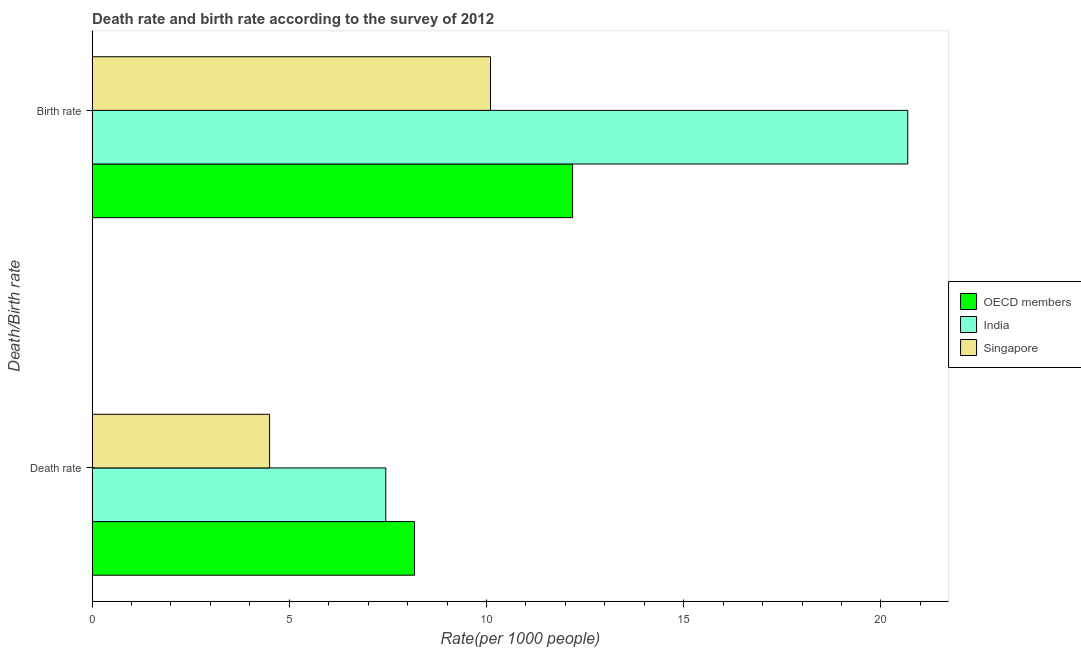How many different coloured bars are there?
Keep it short and to the point. 3. Are the number of bars on each tick of the Y-axis equal?
Provide a succinct answer. Yes. How many bars are there on the 1st tick from the top?
Provide a short and direct response. 3. What is the label of the 1st group of bars from the top?
Keep it short and to the point. Birth rate. What is the death rate in OECD members?
Your response must be concise. 8.17. Across all countries, what is the maximum birth rate?
Make the answer very short. 20.68. Across all countries, what is the minimum death rate?
Provide a short and direct response. 4.5. In which country was the death rate minimum?
Your response must be concise. Singapore. What is the total birth rate in the graph?
Give a very brief answer. 42.96. What is the difference between the birth rate in India and that in OECD members?
Your response must be concise. 8.5. What is the difference between the birth rate in Singapore and the death rate in India?
Provide a succinct answer. 2.65. What is the average birth rate per country?
Your answer should be compact. 14.32. In how many countries, is the death rate greater than 17 ?
Offer a terse response. 0. What is the ratio of the birth rate in Singapore to that in India?
Make the answer very short. 0.49. Is the death rate in Singapore less than that in India?
Provide a succinct answer. Yes. In how many countries, is the birth rate greater than the average birth rate taken over all countries?
Your answer should be very brief. 1. What does the 2nd bar from the top in Death rate represents?
Your answer should be very brief. India. What does the 1st bar from the bottom in Death rate represents?
Your response must be concise. OECD members. What is the difference between two consecutive major ticks on the X-axis?
Keep it short and to the point. 5. Does the graph contain grids?
Keep it short and to the point. No. How many legend labels are there?
Offer a very short reply. 3. How are the legend labels stacked?
Ensure brevity in your answer.  Vertical. What is the title of the graph?
Give a very brief answer. Death rate and birth rate according to the survey of 2012. What is the label or title of the X-axis?
Give a very brief answer. Rate(per 1000 people). What is the label or title of the Y-axis?
Give a very brief answer. Death/Birth rate. What is the Rate(per 1000 people) of OECD members in Death rate?
Provide a succinct answer. 8.17. What is the Rate(per 1000 people) in India in Death rate?
Offer a terse response. 7.45. What is the Rate(per 1000 people) in Singapore in Death rate?
Keep it short and to the point. 4.5. What is the Rate(per 1000 people) of OECD members in Birth rate?
Your response must be concise. 12.18. What is the Rate(per 1000 people) of India in Birth rate?
Offer a very short reply. 20.68. Across all Death/Birth rate, what is the maximum Rate(per 1000 people) in OECD members?
Your answer should be very brief. 12.18. Across all Death/Birth rate, what is the maximum Rate(per 1000 people) in India?
Your answer should be compact. 20.68. Across all Death/Birth rate, what is the minimum Rate(per 1000 people) in OECD members?
Provide a short and direct response. 8.17. Across all Death/Birth rate, what is the minimum Rate(per 1000 people) in India?
Ensure brevity in your answer.  7.45. Across all Death/Birth rate, what is the minimum Rate(per 1000 people) in Singapore?
Your response must be concise. 4.5. What is the total Rate(per 1000 people) of OECD members in the graph?
Your answer should be compact. 20.36. What is the total Rate(per 1000 people) of India in the graph?
Make the answer very short. 28.12. What is the difference between the Rate(per 1000 people) of OECD members in Death rate and that in Birth rate?
Offer a terse response. -4.01. What is the difference between the Rate(per 1000 people) of India in Death rate and that in Birth rate?
Provide a succinct answer. -13.23. What is the difference between the Rate(per 1000 people) of Singapore in Death rate and that in Birth rate?
Keep it short and to the point. -5.6. What is the difference between the Rate(per 1000 people) in OECD members in Death rate and the Rate(per 1000 people) in India in Birth rate?
Ensure brevity in your answer.  -12.5. What is the difference between the Rate(per 1000 people) in OECD members in Death rate and the Rate(per 1000 people) in Singapore in Birth rate?
Give a very brief answer. -1.93. What is the difference between the Rate(per 1000 people) of India in Death rate and the Rate(per 1000 people) of Singapore in Birth rate?
Offer a terse response. -2.65. What is the average Rate(per 1000 people) of OECD members per Death/Birth rate?
Provide a short and direct response. 10.18. What is the average Rate(per 1000 people) in India per Death/Birth rate?
Keep it short and to the point. 14.06. What is the difference between the Rate(per 1000 people) of OECD members and Rate(per 1000 people) of India in Death rate?
Offer a very short reply. 0.73. What is the difference between the Rate(per 1000 people) of OECD members and Rate(per 1000 people) of Singapore in Death rate?
Provide a succinct answer. 3.67. What is the difference between the Rate(per 1000 people) in India and Rate(per 1000 people) in Singapore in Death rate?
Your response must be concise. 2.95. What is the difference between the Rate(per 1000 people) of OECD members and Rate(per 1000 people) of India in Birth rate?
Provide a short and direct response. -8.5. What is the difference between the Rate(per 1000 people) of OECD members and Rate(per 1000 people) of Singapore in Birth rate?
Offer a very short reply. 2.08. What is the difference between the Rate(per 1000 people) of India and Rate(per 1000 people) of Singapore in Birth rate?
Your answer should be compact. 10.58. What is the ratio of the Rate(per 1000 people) of OECD members in Death rate to that in Birth rate?
Your answer should be very brief. 0.67. What is the ratio of the Rate(per 1000 people) of India in Death rate to that in Birth rate?
Keep it short and to the point. 0.36. What is the ratio of the Rate(per 1000 people) of Singapore in Death rate to that in Birth rate?
Give a very brief answer. 0.45. What is the difference between the highest and the second highest Rate(per 1000 people) in OECD members?
Provide a succinct answer. 4.01. What is the difference between the highest and the second highest Rate(per 1000 people) in India?
Give a very brief answer. 13.23. What is the difference between the highest and the lowest Rate(per 1000 people) in OECD members?
Offer a terse response. 4.01. What is the difference between the highest and the lowest Rate(per 1000 people) in India?
Keep it short and to the point. 13.23. 